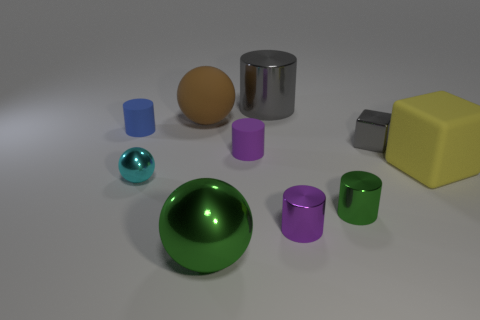What color is the matte block that is the same size as the brown thing?
Keep it short and to the point. Yellow. There is a small metal block; is it the same color as the matte object right of the gray metal cube?
Your answer should be compact. No. What color is the tiny metallic sphere?
Your answer should be very brief. Cyan. What is the large cylinder that is behind the purple metal cylinder made of?
Offer a very short reply. Metal. What size is the green object that is the same shape as the blue thing?
Offer a terse response. Small. Are there fewer large shiny cylinders in front of the small purple matte thing than cyan metal balls?
Provide a short and direct response. Yes. Are any big gray things visible?
Provide a succinct answer. Yes. There is a large rubber object that is the same shape as the small gray metal thing; what is its color?
Give a very brief answer. Yellow. There is a big shiny thing behind the small cyan ball; is it the same color as the tiny shiny ball?
Offer a terse response. No. Do the blue cylinder and the yellow object have the same size?
Your answer should be very brief. No. 